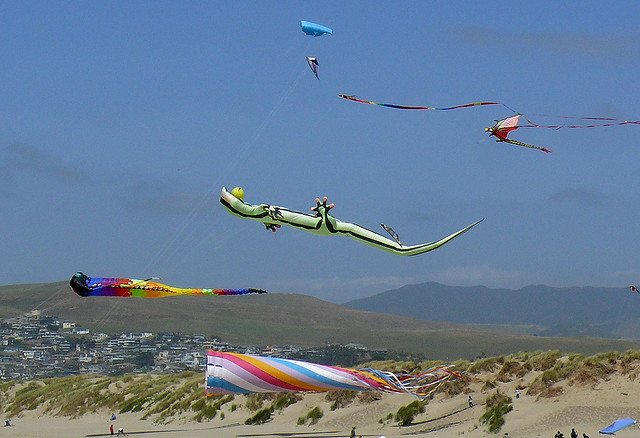<image>What type of art is shown? I don't know the type of art shown. It can be either kites or tye dye. What type of art is shown? I don't know what type of art is shown. It can be seen as 'kites' or 'kite art'. 